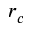Convert formula to latex. <formula><loc_0><loc_0><loc_500><loc_500>r _ { c }</formula> 